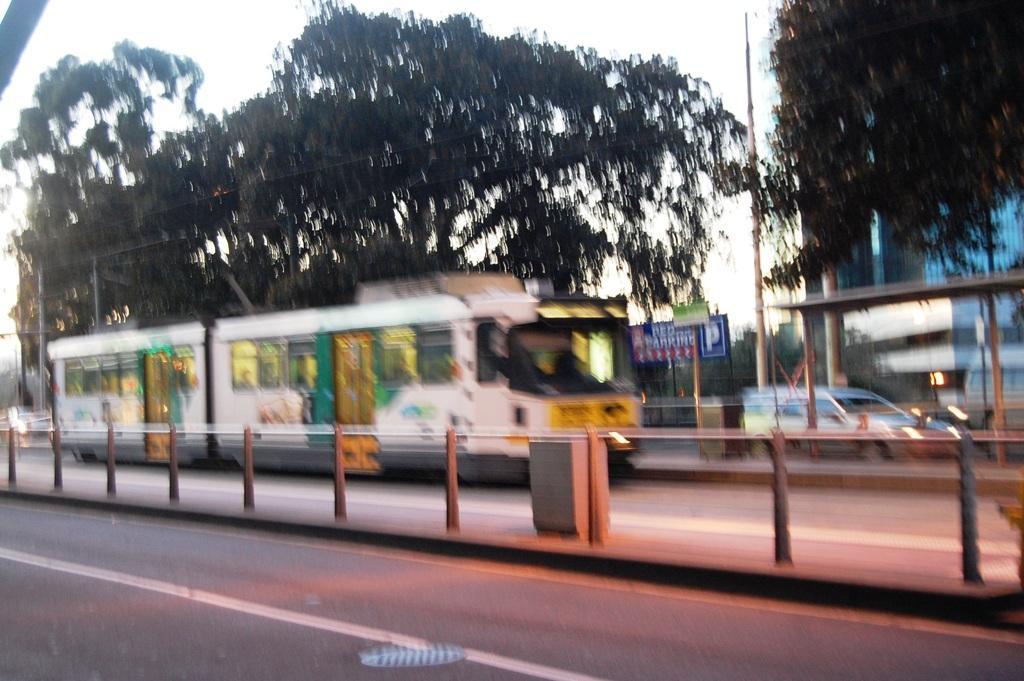How would you summarize this image in a sentence or two? In this image I can see a divider, few vehicles on the road, in front the vehicle is in white color, trees in green color, a building and the sky is in white color. 